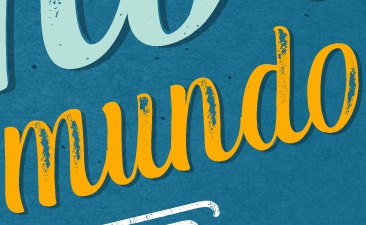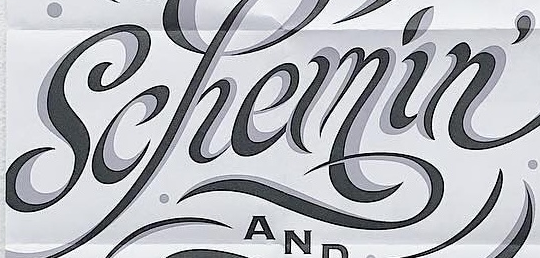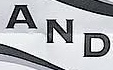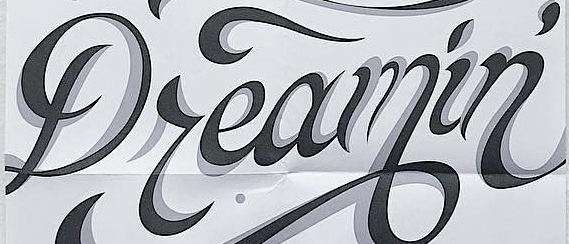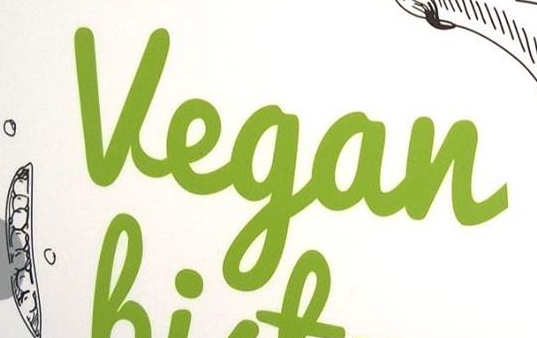Identify the words shown in these images in order, separated by a semicolon. mundo; Schemin'; AND; Dreamin'; Vegan 